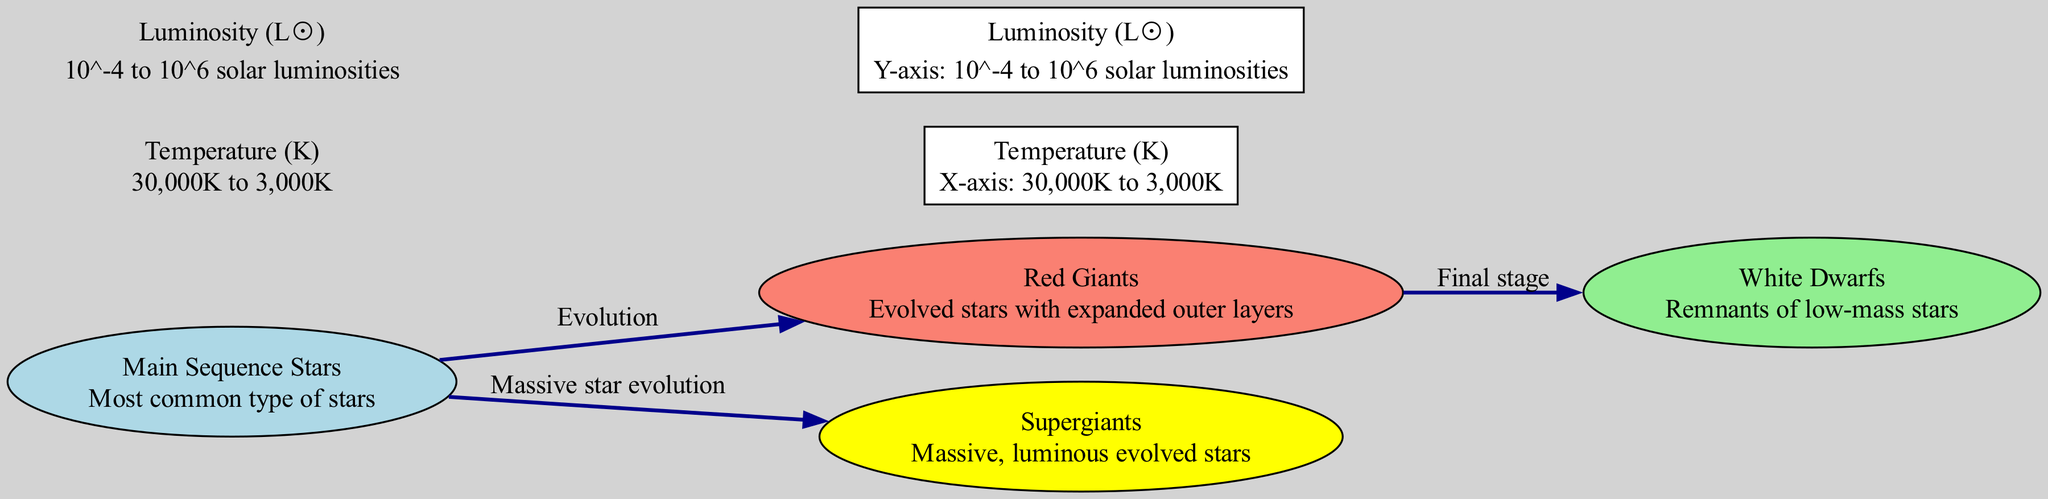¿Qué tipo de estrellas son las más comunes según el diagrama? En el diagrama, la etiqueta correspondiente a las estrellas más comunes es "Main Sequence Stars". Esto se identifica al observar que este nodo no solo aparece como el más prominente, sino que también se encuentra en el centro del gráfico, indicando su relevancia en la clasificación estelar.
Answer: Main Sequence Stars ¿Cuál es la relación entre las estrellas gigantes rojas y las enanas blancas? Al analizar el diagrama, se observa que hay una flecha etiquetada como "Final stage" que conecta el nodo de "Red Giants" al nodo de "White Dwarfs". Esto significa que en el proceso evolutivo, las estrellas gigantes rojas se convierten en enanas blancas.
Answer: Final stage ¿Qué representa el eje Y del diagrama? En el diagrama, el eje Y está etiquetado como "Luminosity (L☉)", que indica que mide la luminosidad en términos de luminosidades solares. Esta información es clave para entender cómo es clasificada la luminosidad de las estrellas dentro del contexto presentando en el diagrama.
Answer: Luminosity (L☉) ¿Cuántos nodos hay en total en el diagrama? Al contar los nodos que están visualmente representados en el diagrama, se identifica que hay un total de seis nodos: cuatro diferentes tipos de estrellas y dos ejes. Esto se puede concluir sumando los nodos que aparecen, ya que son elementos claramente diferenciados en la visualización.
Answer: 6 ¿Qué tipo de estrellas evolucionan hacia supergigantes? En el diagrama, se puede observar que existe una flecha etiquetada como "Massive star evolution" que conecta "Main Sequence Stars" a "Supergiants". Esto indica que las estrellas de la secuencia principal que tienen una masa considerable evolucionan a supergigantes.
Answer: Massive star evolution ¿Qué rango de temperatura se muestra en el eje X? El eje X está etiquetado "Temperature (K)" con un rango que va desde 30,000K hasta 3,000K. Este rango de temperatura es crucial para la comprensión de cómo se clasifican las estrellas en el diagrama según su temperatura superficial.
Answer: 30,000K to 3,000K 